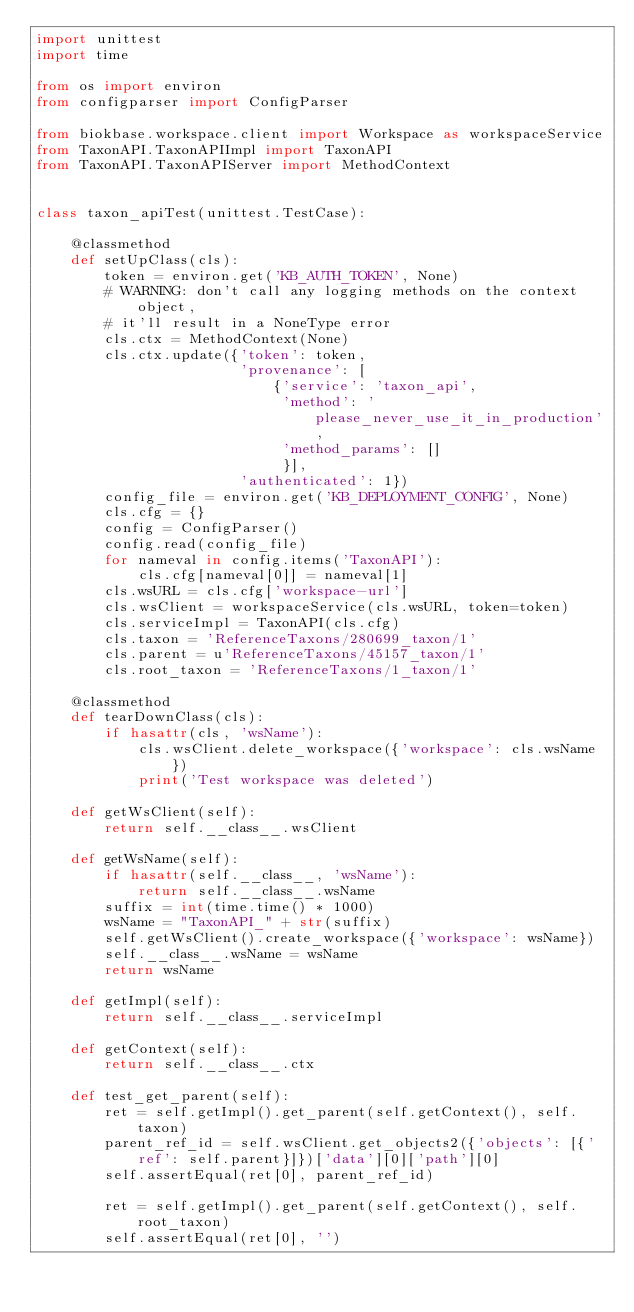<code> <loc_0><loc_0><loc_500><loc_500><_Python_>import unittest
import time

from os import environ
from configparser import ConfigParser

from biokbase.workspace.client import Workspace as workspaceService
from TaxonAPI.TaxonAPIImpl import TaxonAPI
from TaxonAPI.TaxonAPIServer import MethodContext


class taxon_apiTest(unittest.TestCase):

    @classmethod
    def setUpClass(cls):
        token = environ.get('KB_AUTH_TOKEN', None)
        # WARNING: don't call any logging methods on the context object,
        # it'll result in a NoneType error
        cls.ctx = MethodContext(None)
        cls.ctx.update({'token': token,
                        'provenance': [
                            {'service': 'taxon_api',
                             'method': 'please_never_use_it_in_production',
                             'method_params': []
                             }],
                        'authenticated': 1})
        config_file = environ.get('KB_DEPLOYMENT_CONFIG', None)
        cls.cfg = {}
        config = ConfigParser()
        config.read(config_file)
        for nameval in config.items('TaxonAPI'):
            cls.cfg[nameval[0]] = nameval[1]
        cls.wsURL = cls.cfg['workspace-url']
        cls.wsClient = workspaceService(cls.wsURL, token=token)
        cls.serviceImpl = TaxonAPI(cls.cfg)
        cls.taxon = 'ReferenceTaxons/280699_taxon/1'
        cls.parent = u'ReferenceTaxons/45157_taxon/1'
        cls.root_taxon = 'ReferenceTaxons/1_taxon/1'

    @classmethod
    def tearDownClass(cls):
        if hasattr(cls, 'wsName'):
            cls.wsClient.delete_workspace({'workspace': cls.wsName})
            print('Test workspace was deleted')

    def getWsClient(self):
        return self.__class__.wsClient

    def getWsName(self):
        if hasattr(self.__class__, 'wsName'):
            return self.__class__.wsName
        suffix = int(time.time() * 1000)
        wsName = "TaxonAPI_" + str(suffix)
        self.getWsClient().create_workspace({'workspace': wsName})
        self.__class__.wsName = wsName
        return wsName

    def getImpl(self):
        return self.__class__.serviceImpl

    def getContext(self):
        return self.__class__.ctx

    def test_get_parent(self):
        ret = self.getImpl().get_parent(self.getContext(), self.taxon)
        parent_ref_id = self.wsClient.get_objects2({'objects': [{'ref': self.parent}]})['data'][0]['path'][0]
        self.assertEqual(ret[0], parent_ref_id)

        ret = self.getImpl().get_parent(self.getContext(), self.root_taxon)
        self.assertEqual(ret[0], '')
</code> 